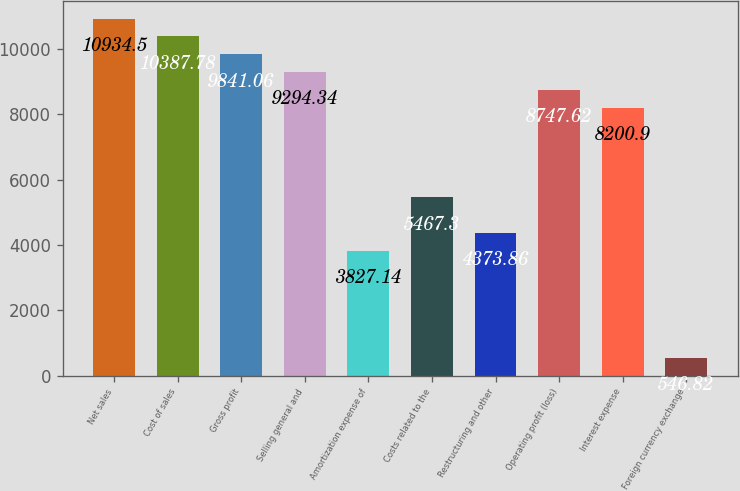<chart> <loc_0><loc_0><loc_500><loc_500><bar_chart><fcel>Net sales<fcel>Cost of sales<fcel>Gross profit<fcel>Selling general and<fcel>Amortization expense of<fcel>Costs related to the<fcel>Restructuring and other<fcel>Operating profit (loss)<fcel>Interest expense<fcel>Foreign currency exchange<nl><fcel>10934.5<fcel>10387.8<fcel>9841.06<fcel>9294.34<fcel>3827.14<fcel>5467.3<fcel>4373.86<fcel>8747.62<fcel>8200.9<fcel>546.82<nl></chart> 